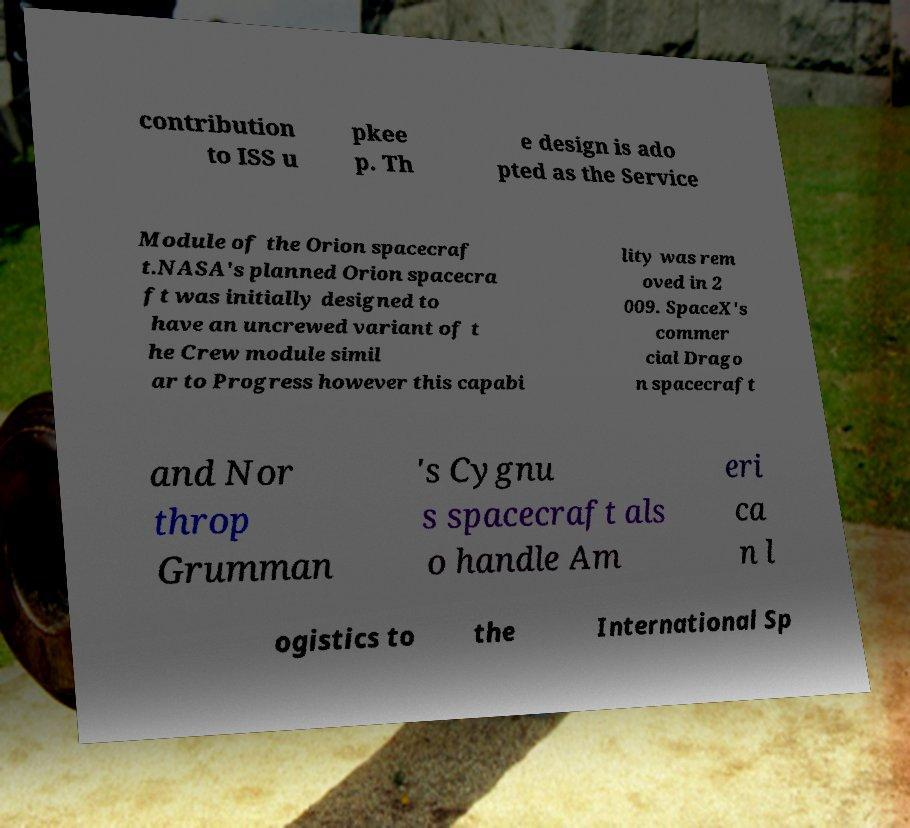Please identify and transcribe the text found in this image. contribution to ISS u pkee p. Th e design is ado pted as the Service Module of the Orion spacecraf t.NASA's planned Orion spacecra ft was initially designed to have an uncrewed variant of t he Crew module simil ar to Progress however this capabi lity was rem oved in 2 009. SpaceX's commer cial Drago n spacecraft and Nor throp Grumman 's Cygnu s spacecraft als o handle Am eri ca n l ogistics to the International Sp 